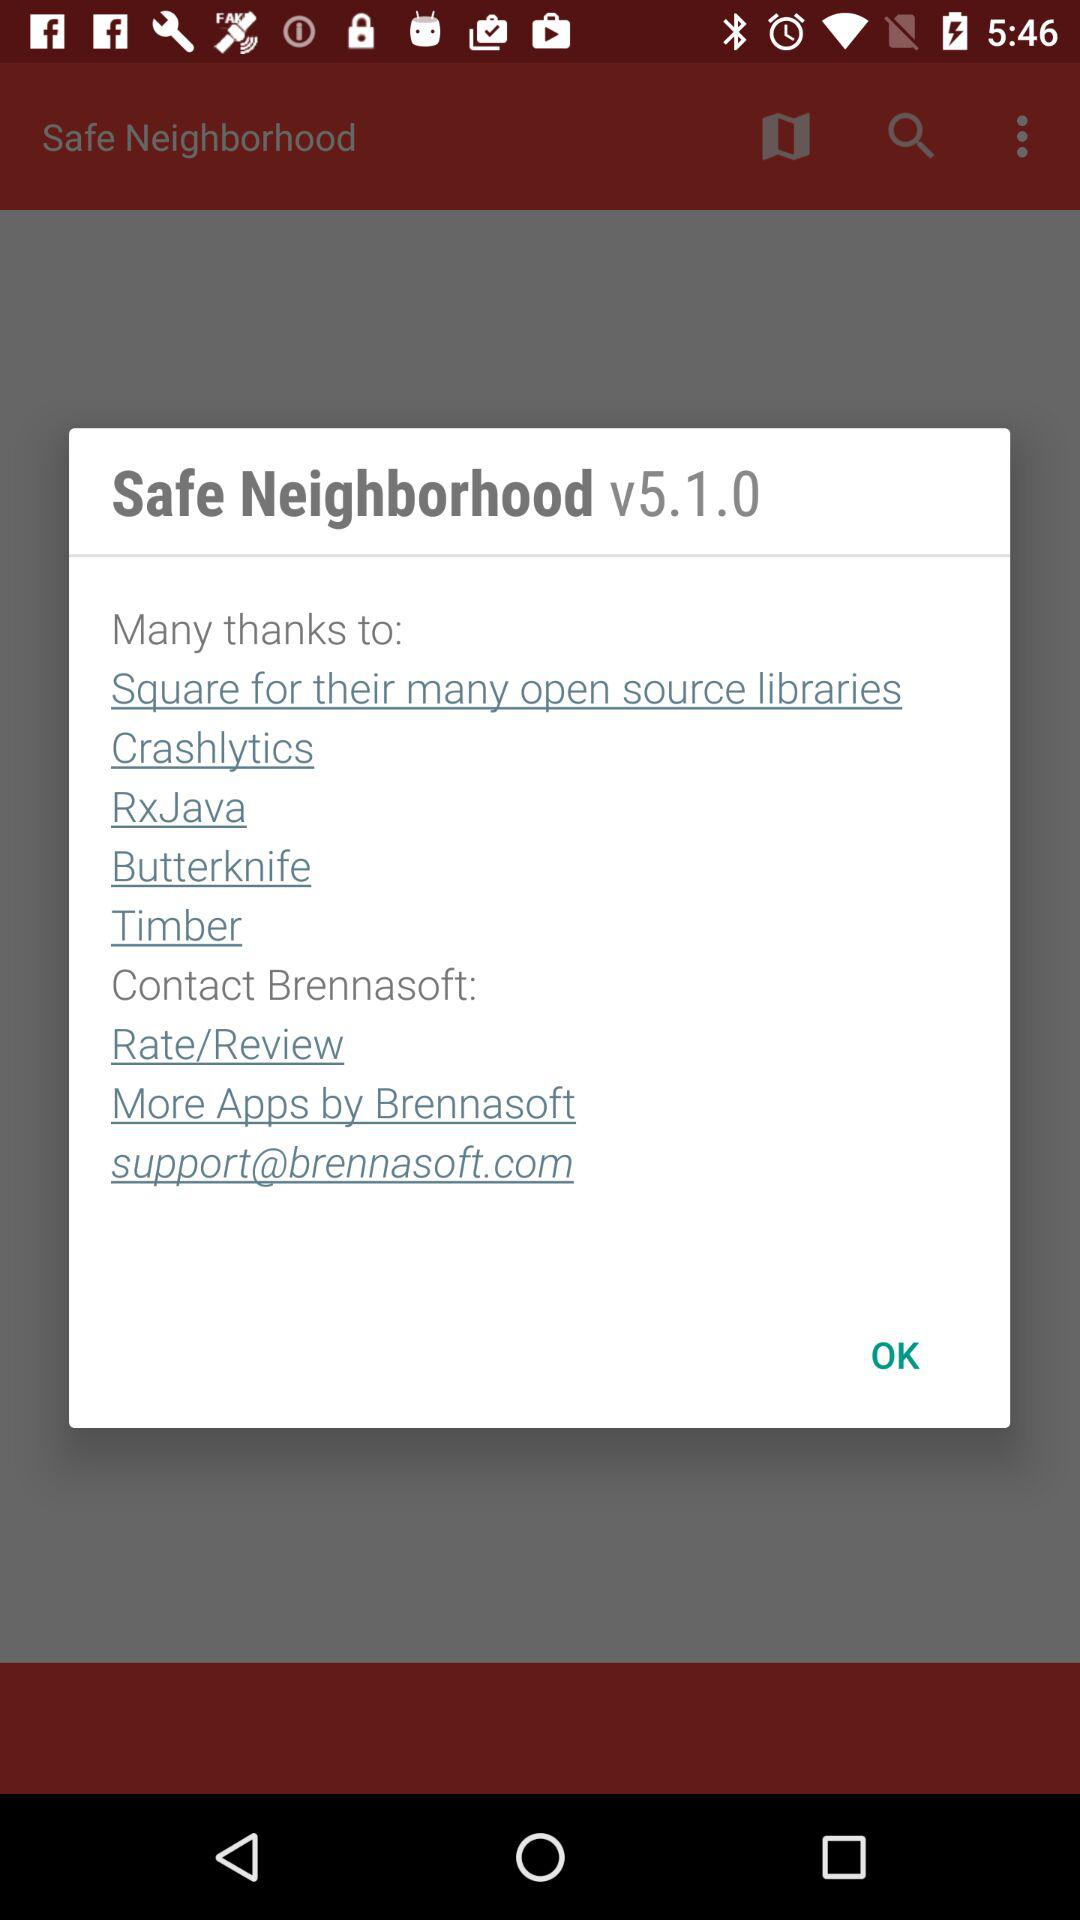What is the email address? The email address is support@brennasoft.com. 